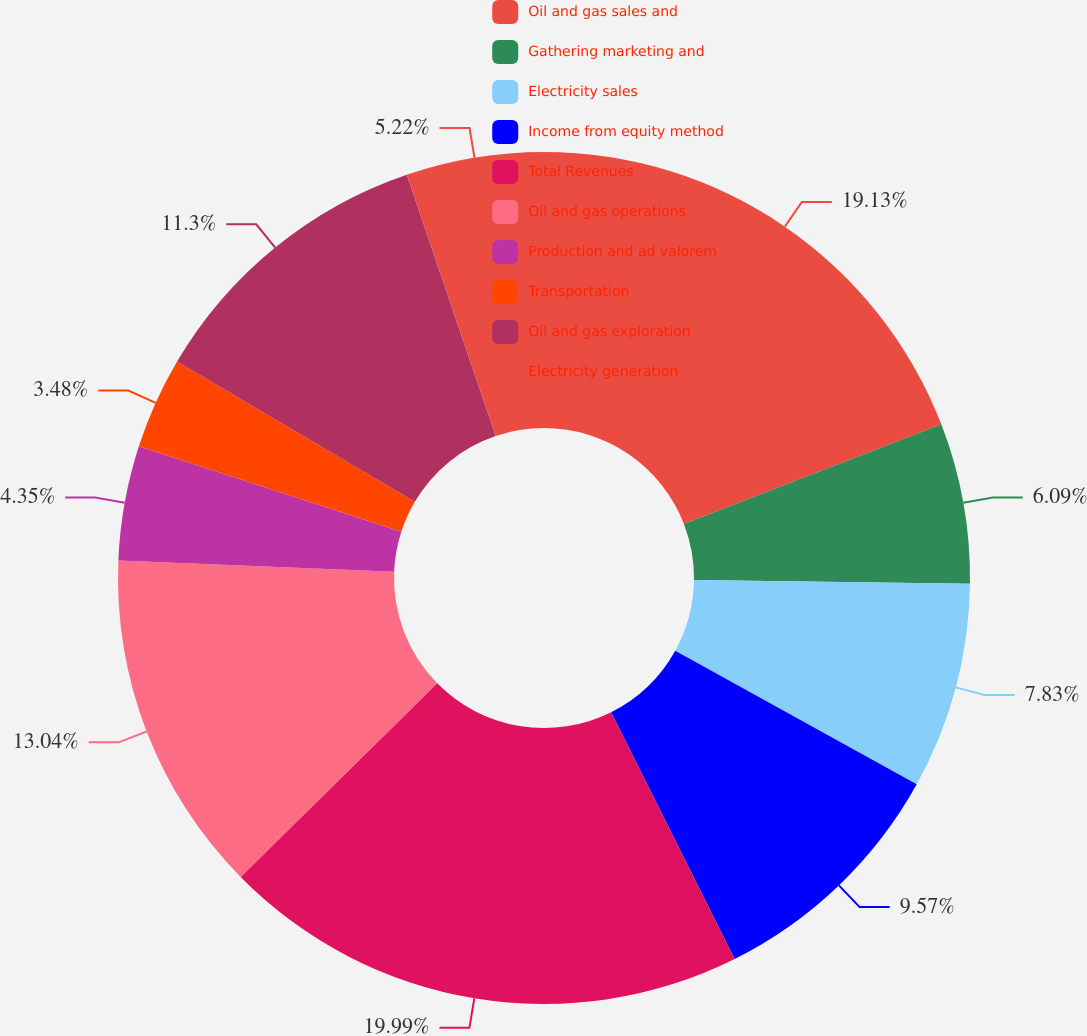<chart> <loc_0><loc_0><loc_500><loc_500><pie_chart><fcel>Oil and gas sales and<fcel>Gathering marketing and<fcel>Electricity sales<fcel>Income from equity method<fcel>Total Revenues<fcel>Oil and gas operations<fcel>Production and ad valorem<fcel>Transportation<fcel>Oil and gas exploration<fcel>Electricity generation<nl><fcel>19.13%<fcel>6.09%<fcel>7.83%<fcel>9.57%<fcel>20.0%<fcel>13.04%<fcel>4.35%<fcel>3.48%<fcel>11.3%<fcel>5.22%<nl></chart> 